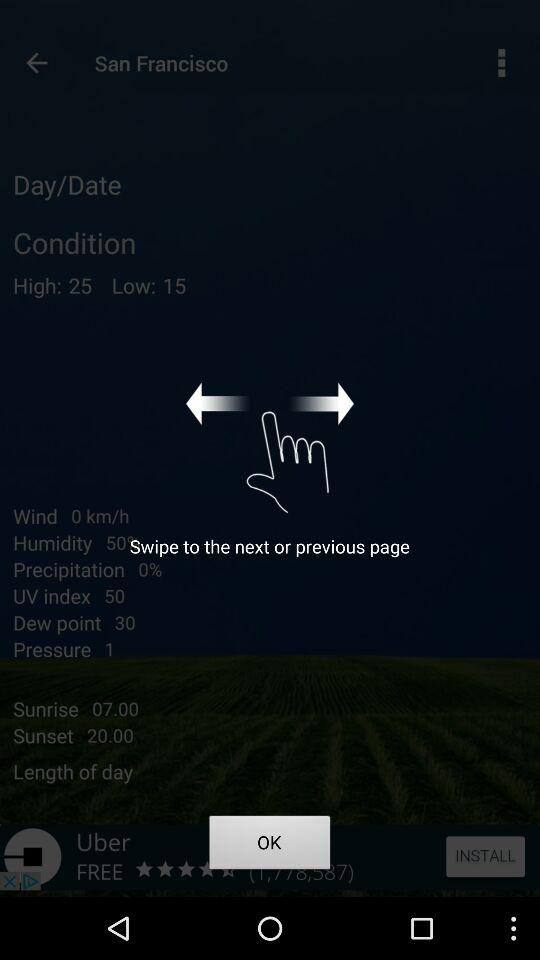What time is sunset? The time is 20.00. 